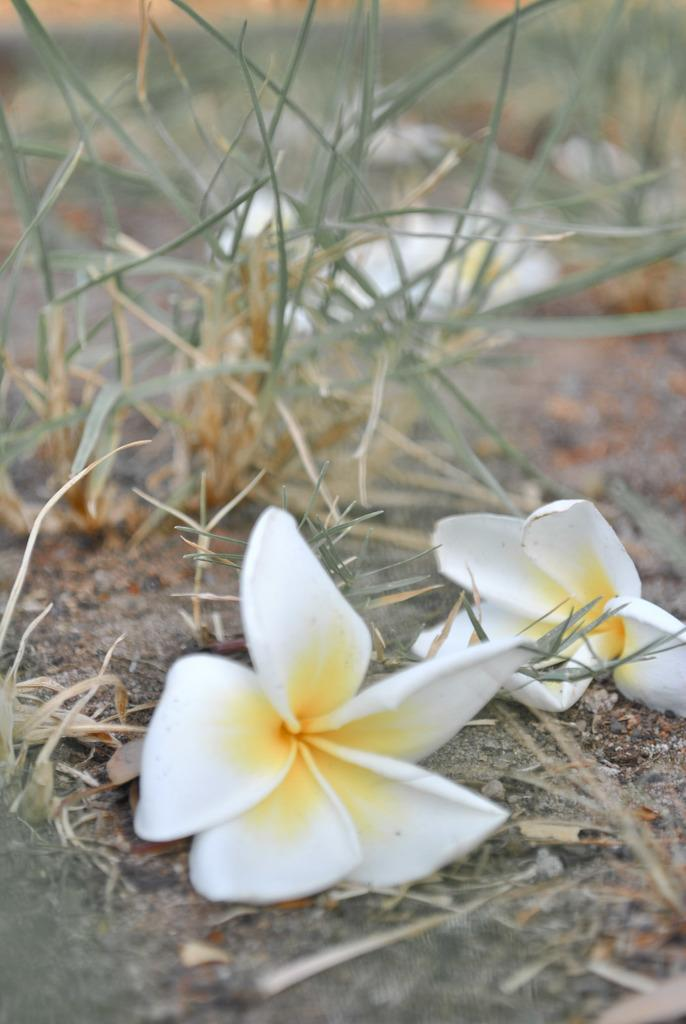What type of vegetation can be seen on the ground in the image? There are flowers on the ground in the image. What other natural element is visible in the image? There is grass visible in the image. Can you describe the background of the image? The background of the image is blurry. What type of hook can be seen hanging from the tree in the image? There is no hook present in the image; it only features flowers on the ground and grass. Can you describe the cat's behavior in the image? There is no cat present in the image. 